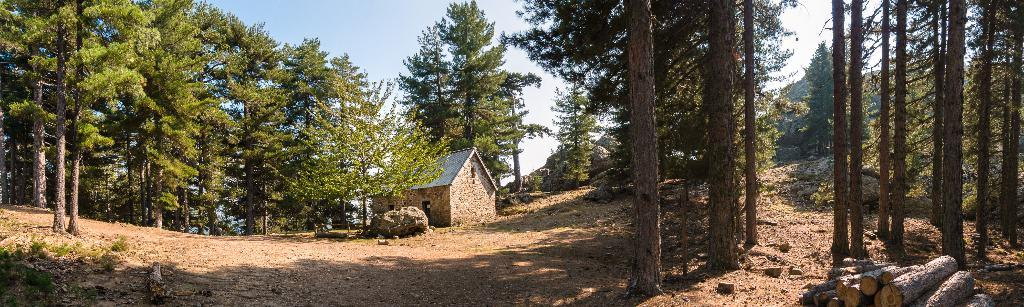What type of vegetation can be seen in the image? There are trees in the image. What is the color of the trees? The trees are green in color. What structure is present in the image? There is a house in the image. What can be seen in the background of the image? The sky is visible in the background of the image. What colors are present in the sky? The sky has a combination of white and blue colors. Can you recall any memories of visiting the zoo in the image? There is no mention of a zoo or any memories in the image; it features trees, a house, and a sky with white and blue colors. 